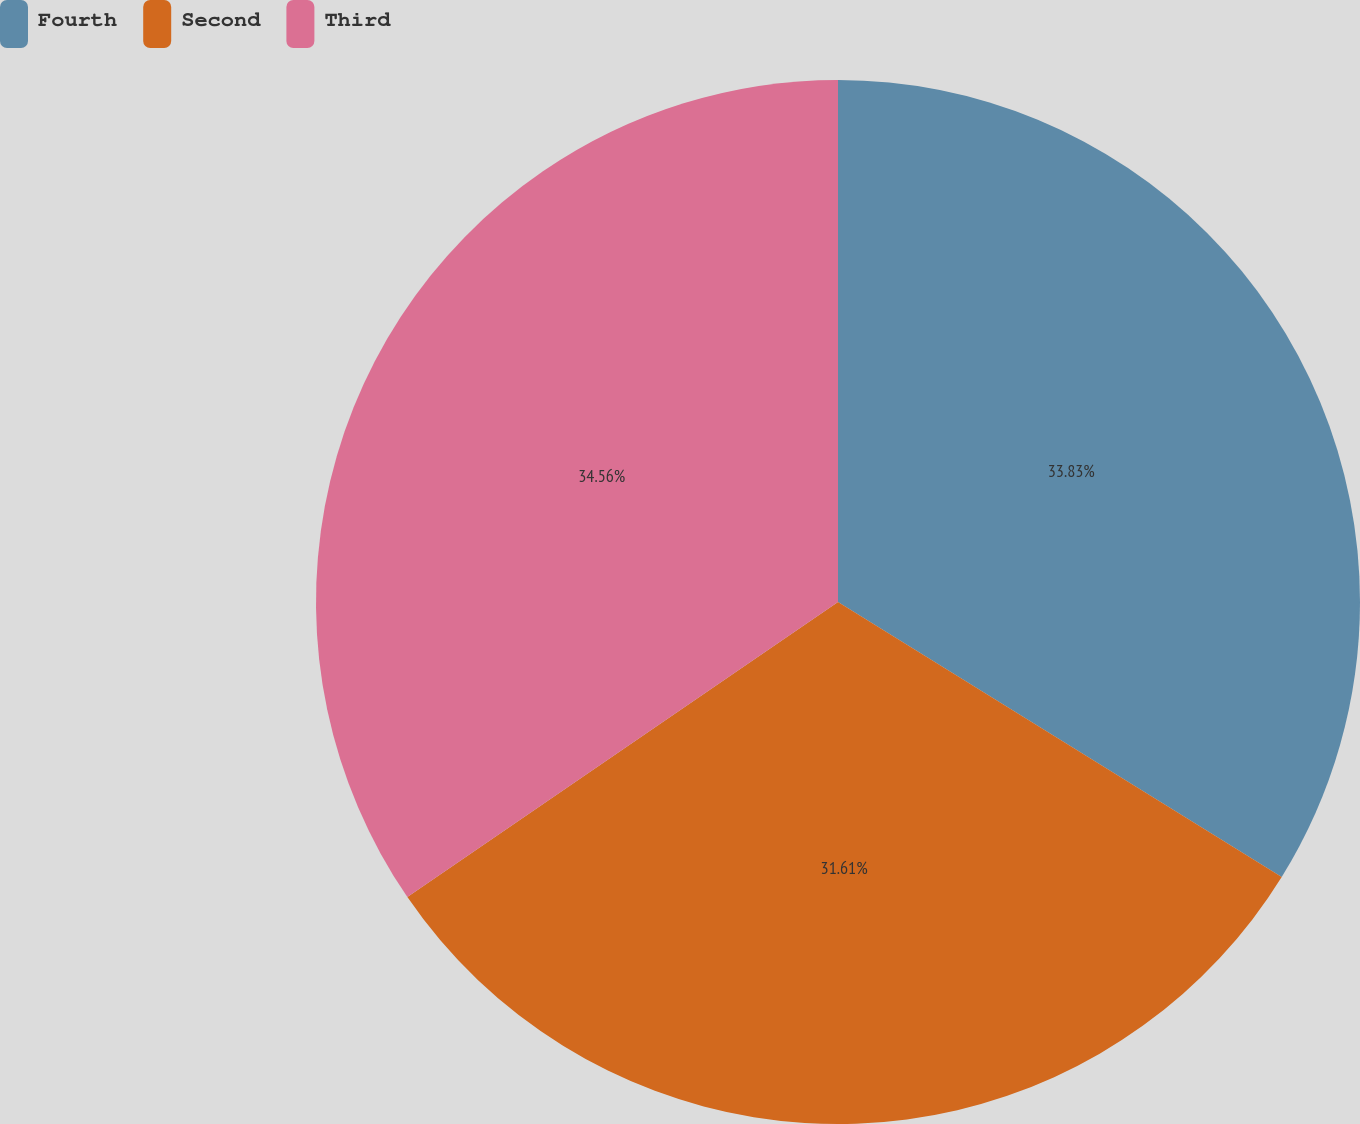Convert chart. <chart><loc_0><loc_0><loc_500><loc_500><pie_chart><fcel>Fourth<fcel>Second<fcel>Third<nl><fcel>33.83%<fcel>31.61%<fcel>34.56%<nl></chart> 